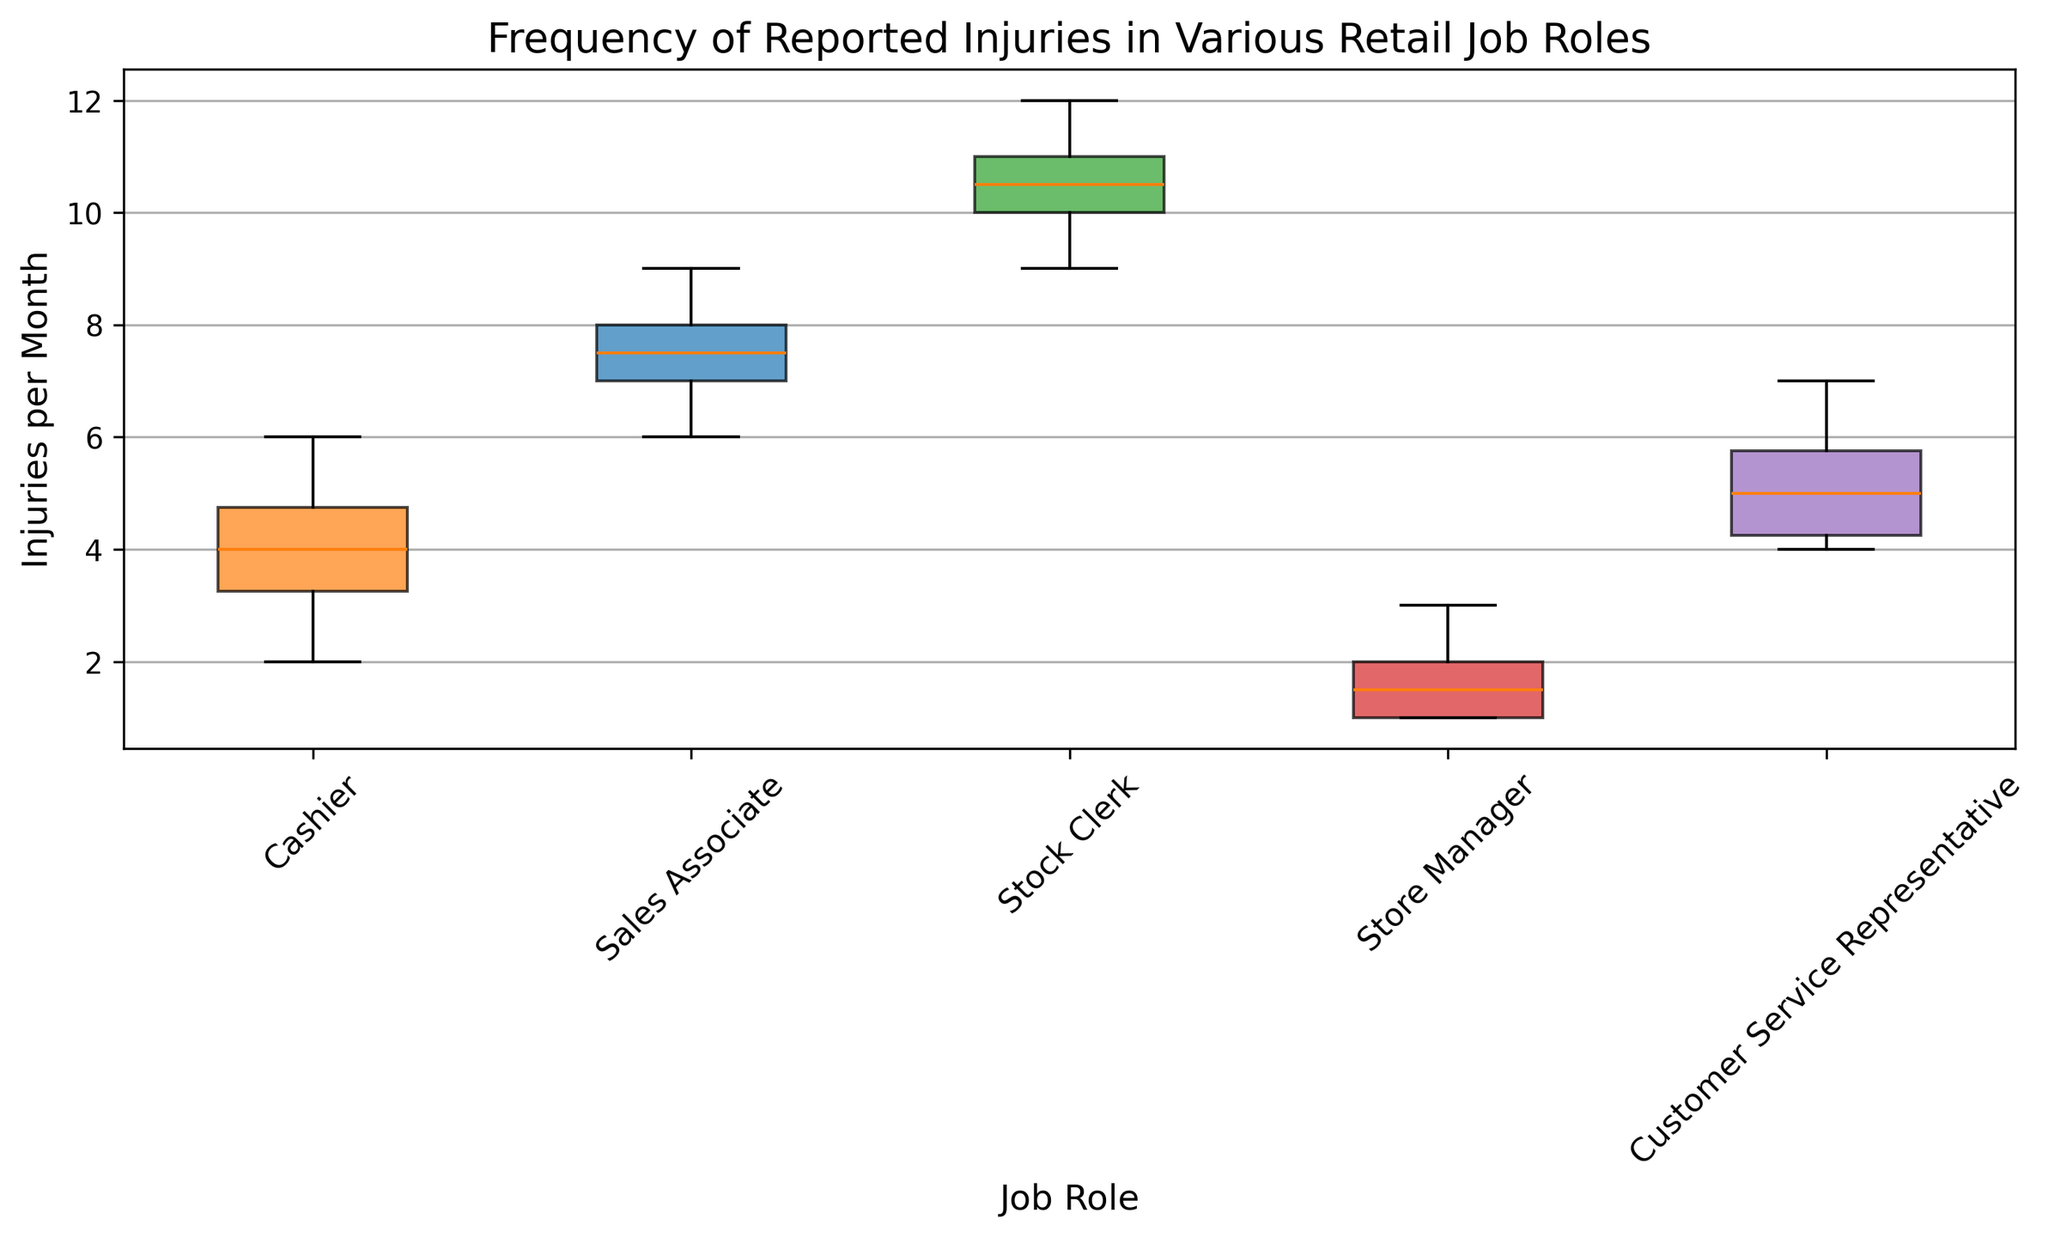What is the median number of injuries per month for Cashiers? To determine the median number of injuries for Cashiers, we need to arrange their injury counts in ascending order: [2, 3, 4, 4, 5, 6]. Since there are six data points, the median will be the average of the third and fourth values, which are both 4. Therefore, the median is (4 + 4)/2 = 4
Answer: 4 Which job role has the highest median number of injuries per month? By comparing the central line (representing the median) of each boxplot, we can see which job role has the highest median. The Stock Clerk’s boxplot has the highest central line, clearly above the others.
Answer: Stock Clerk How do the ranges of reported injuries for Sales Associates and Customer Service Representatives compare? To compare the ranges, we observe the length of the boxes (indicates the interquartile range) and whiskers (indicates the total range) for both job roles. Sales Associates have a range roughly between 6 and 9 (IQR ≈ 7.5 - 6.5 = 1), while Customer Service Representatives have a range roughly between 4 and 7 (IQR ≈ 6 - 4.5 = 1.5). Despite similar IQRs, the broader total range of injuries is similar.
Answer: Similar ranges Which job role shows the least variability in reported injuries? Variability is visually represented by the spread of the boxplot. The job role with the narrowest boxplot width has the least variability. The Store Manager’s boxplot is the narrowest, indicating the least variability.
Answer: Store Manager What is the interquartile range (IQR) of injuries per month for Stock Clerks? The IQR is found by subtracting the first quartile (Q1) from the third quartile (Q3). Stock Clerks’ injury counts fall predominantly between 10 and 11. This suggests an approximate IQR of 11 - 10 = 1.
Answer: 1 Which job role has the highest maximum reported injury per month? To find this, we check the uppermost part of the whiskers (lines extending from the boxes). The Stock Clerk’s whisker extends the highest, thus indicating the highest maximum reported injuries.
Answer: Stock Clerk Do any job roles have outliers in their reported injuries? Outliers are typically represented as individual points outside the whiskers. By examining the graphs, none of the boxplots show individual points that would indicate outliers.
Answer: No Comparing the medians, are Store Managers or Cashiers more likely to report higher injuries per month? We compare the medians of Store Managers and Cashiers by looking at the central line of their respective boxplots. Cashiers have a median of 4, while Store Managers have a median of around 2. Thus, Cashiers report higher injuries.
Answer: Cashiers 